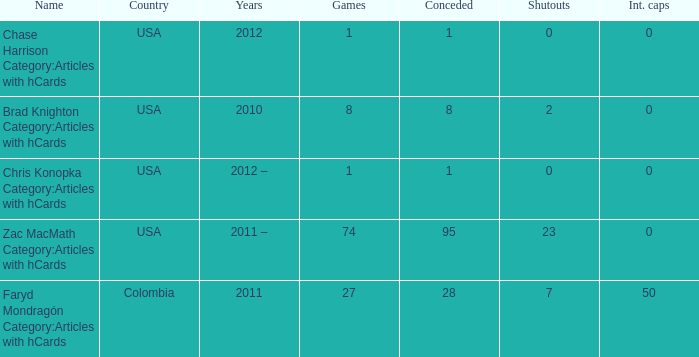When chase harrison category:articles with hcards is the name what is the year? 2012.0. 